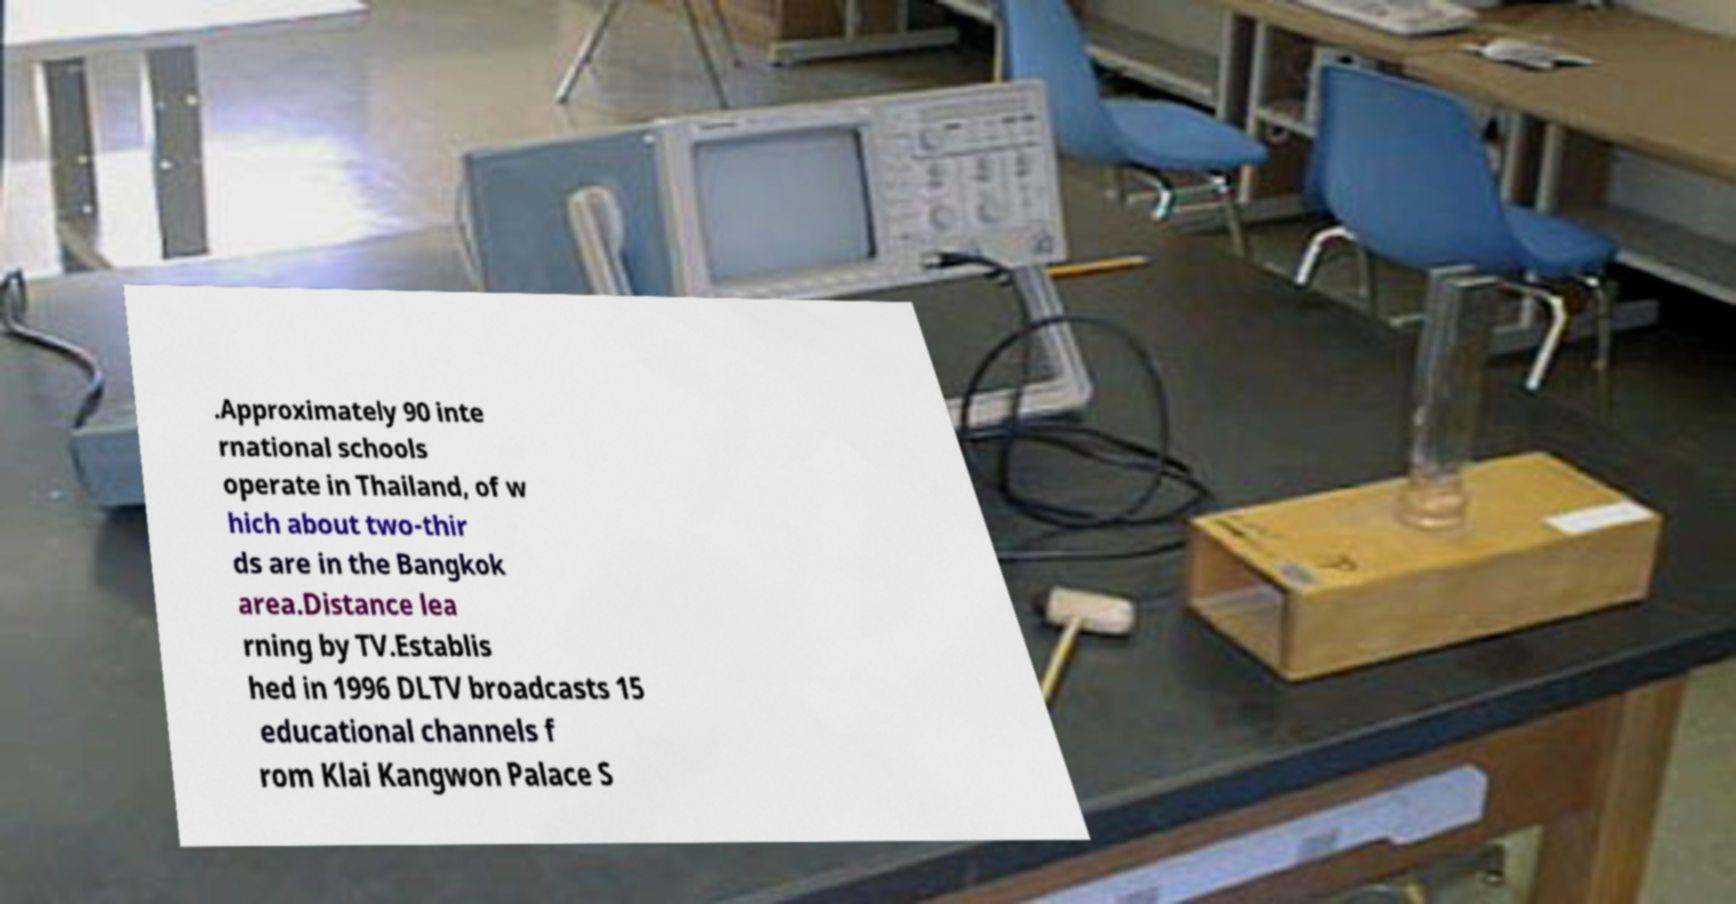Could you assist in decoding the text presented in this image and type it out clearly? .Approximately 90 inte rnational schools operate in Thailand, of w hich about two-thir ds are in the Bangkok area.Distance lea rning by TV.Establis hed in 1996 DLTV broadcasts 15 educational channels f rom Klai Kangwon Palace S 